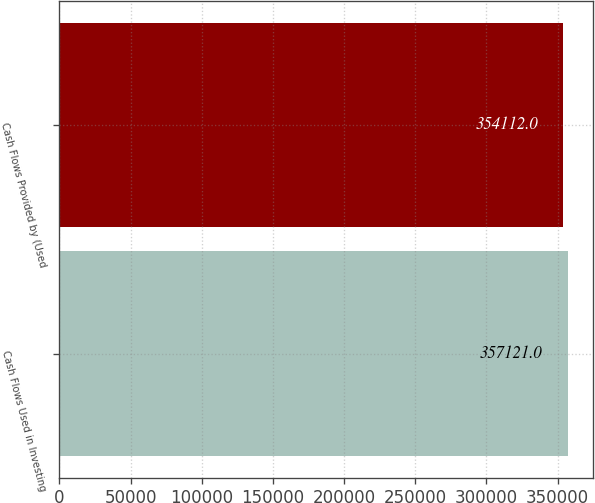Convert chart. <chart><loc_0><loc_0><loc_500><loc_500><bar_chart><fcel>Cash Flows Used in Investing<fcel>Cash Flows Provided by (Used<nl><fcel>357121<fcel>354112<nl></chart> 